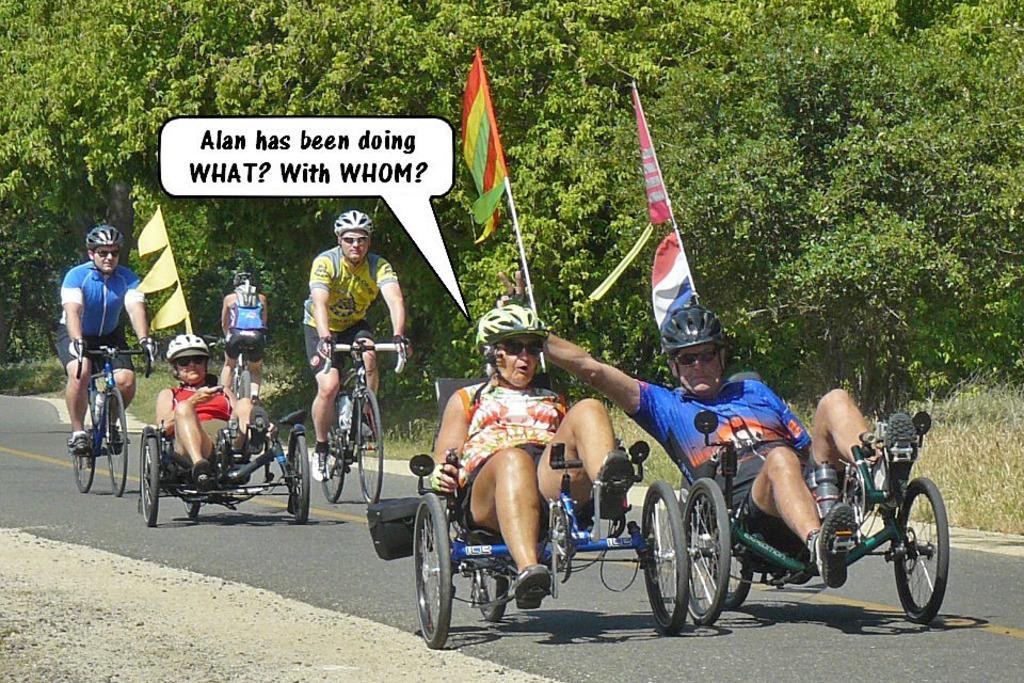How would you summarize this image in a sentence or two? The image is taken on the road. There are people who are riding tricycles and bicycles on the road. There is a flag. In the background there are many trees. 